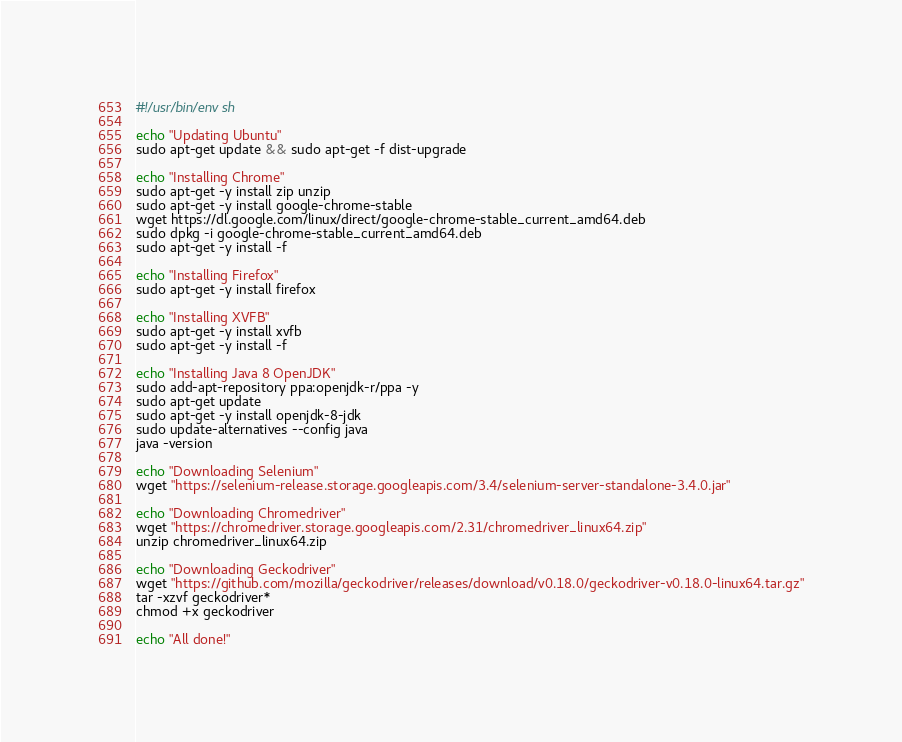Convert code to text. <code><loc_0><loc_0><loc_500><loc_500><_Bash_>#!/usr/bin/env sh

echo "Updating Ubuntu"
sudo apt-get update && sudo apt-get -f dist-upgrade

echo "Installing Chrome"
sudo apt-get -y install zip unzip
sudo apt-get -y install google-chrome-stable
wget https://dl.google.com/linux/direct/google-chrome-stable_current_amd64.deb
sudo dpkg -i google-chrome-stable_current_amd64.deb
sudo apt-get -y install -f

echo "Installing Firefox"
sudo apt-get -y install firefox

echo "Installing XVFB"
sudo apt-get -y install xvfb
sudo apt-get -y install -f

echo "Installing Java 8 OpenJDK"
sudo add-apt-repository ppa:openjdk-r/ppa -y
sudo apt-get update
sudo apt-get -y install openjdk-8-jdk
sudo update-alternatives --config java
java -version

echo "Downloading Selenium"
wget "https://selenium-release.storage.googleapis.com/3.4/selenium-server-standalone-3.4.0.jar"

echo "Downloading Chromedriver"
wget "https://chromedriver.storage.googleapis.com/2.31/chromedriver_linux64.zip"
unzip chromedriver_linux64.zip

echo "Downloading Geckodriver"
wget "https://github.com/mozilla/geckodriver/releases/download/v0.18.0/geckodriver-v0.18.0-linux64.tar.gz"
tar -xzvf geckodriver*
chmod +x geckodriver

echo "All done!"
</code> 